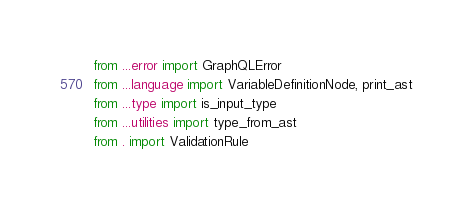<code> <loc_0><loc_0><loc_500><loc_500><_Python_>from ...error import GraphQLError
from ...language import VariableDefinitionNode, print_ast
from ...type import is_input_type
from ...utilities import type_from_ast
from . import ValidationRule
</code> 